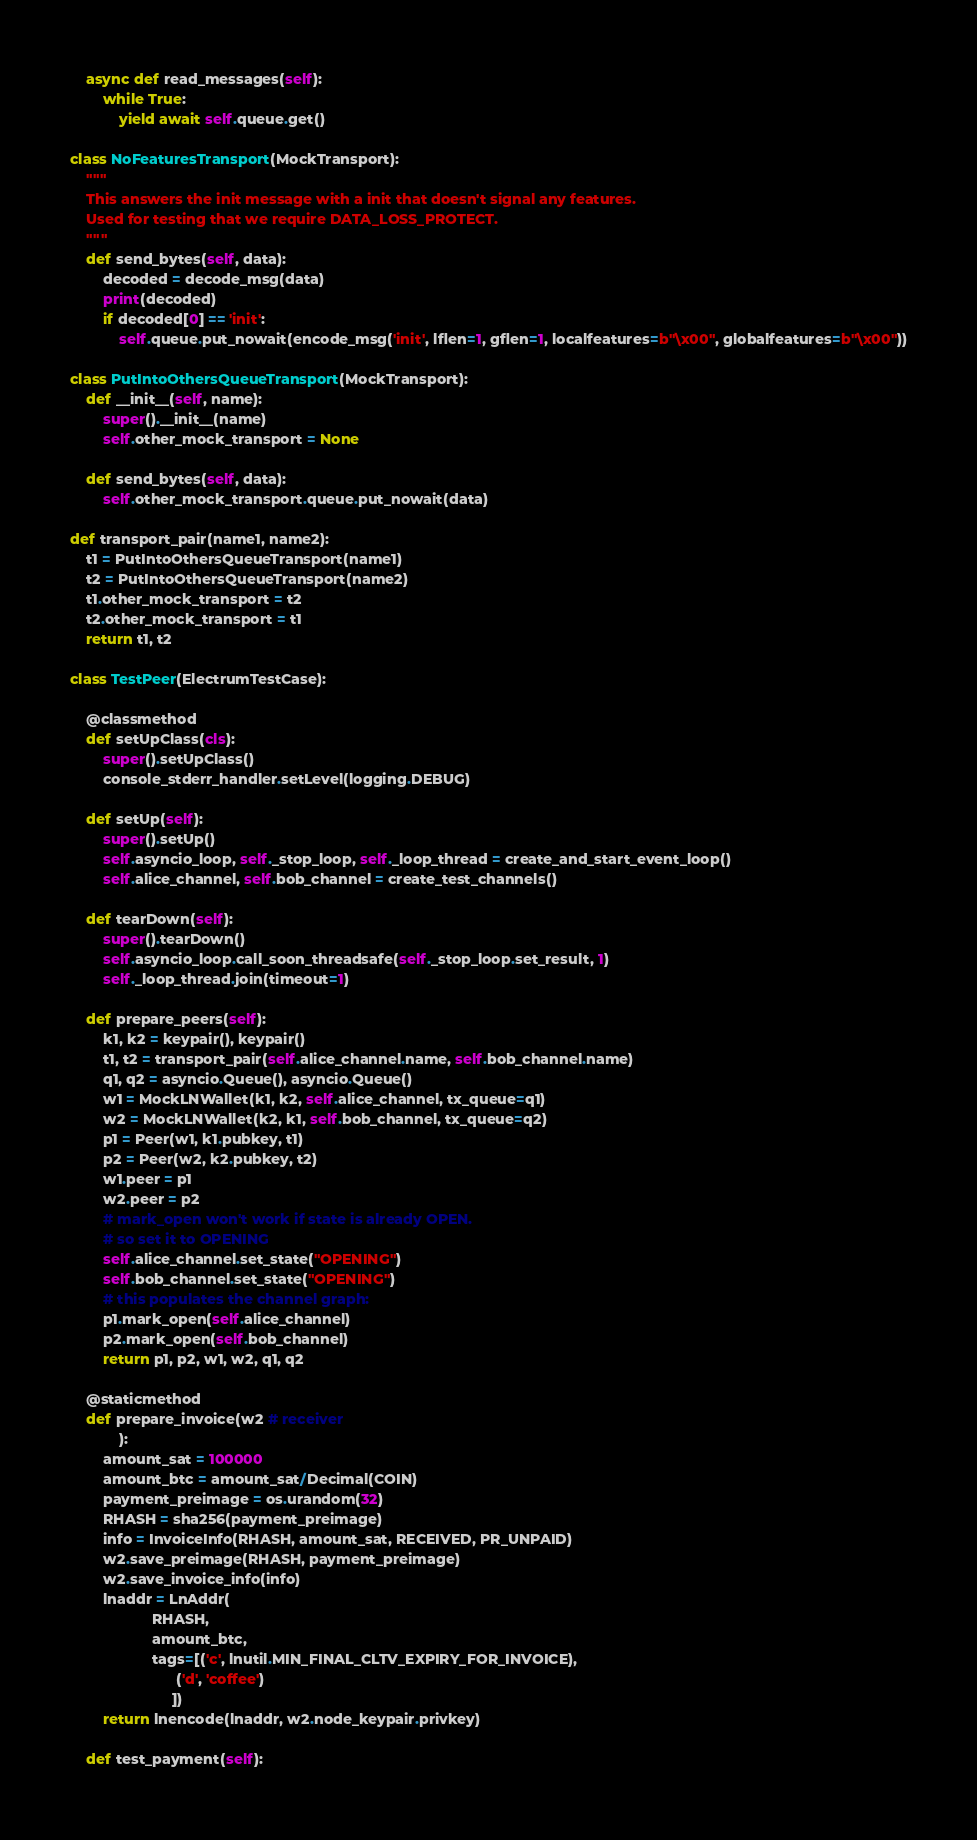Convert code to text. <code><loc_0><loc_0><loc_500><loc_500><_Python_>    async def read_messages(self):
        while True:
            yield await self.queue.get()

class NoFeaturesTransport(MockTransport):
    """
    This answers the init message with a init that doesn't signal any features.
    Used for testing that we require DATA_LOSS_PROTECT.
    """
    def send_bytes(self, data):
        decoded = decode_msg(data)
        print(decoded)
        if decoded[0] == 'init':
            self.queue.put_nowait(encode_msg('init', lflen=1, gflen=1, localfeatures=b"\x00", globalfeatures=b"\x00"))

class PutIntoOthersQueueTransport(MockTransport):
    def __init__(self, name):
        super().__init__(name)
        self.other_mock_transport = None

    def send_bytes(self, data):
        self.other_mock_transport.queue.put_nowait(data)

def transport_pair(name1, name2):
    t1 = PutIntoOthersQueueTransport(name1)
    t2 = PutIntoOthersQueueTransport(name2)
    t1.other_mock_transport = t2
    t2.other_mock_transport = t1
    return t1, t2

class TestPeer(ElectrumTestCase):

    @classmethod
    def setUpClass(cls):
        super().setUpClass()
        console_stderr_handler.setLevel(logging.DEBUG)

    def setUp(self):
        super().setUp()
        self.asyncio_loop, self._stop_loop, self._loop_thread = create_and_start_event_loop()
        self.alice_channel, self.bob_channel = create_test_channels()

    def tearDown(self):
        super().tearDown()
        self.asyncio_loop.call_soon_threadsafe(self._stop_loop.set_result, 1)
        self._loop_thread.join(timeout=1)

    def prepare_peers(self):
        k1, k2 = keypair(), keypair()
        t1, t2 = transport_pair(self.alice_channel.name, self.bob_channel.name)
        q1, q2 = asyncio.Queue(), asyncio.Queue()
        w1 = MockLNWallet(k1, k2, self.alice_channel, tx_queue=q1)
        w2 = MockLNWallet(k2, k1, self.bob_channel, tx_queue=q2)
        p1 = Peer(w1, k1.pubkey, t1)
        p2 = Peer(w2, k2.pubkey, t2)
        w1.peer = p1
        w2.peer = p2
        # mark_open won't work if state is already OPEN.
        # so set it to OPENING
        self.alice_channel.set_state("OPENING")
        self.bob_channel.set_state("OPENING")
        # this populates the channel graph:
        p1.mark_open(self.alice_channel)
        p2.mark_open(self.bob_channel)
        return p1, p2, w1, w2, q1, q2

    @staticmethod
    def prepare_invoice(w2 # receiver
            ):
        amount_sat = 100000
        amount_btc = amount_sat/Decimal(COIN)
        payment_preimage = os.urandom(32)
        RHASH = sha256(payment_preimage)
        info = InvoiceInfo(RHASH, amount_sat, RECEIVED, PR_UNPAID)
        w2.save_preimage(RHASH, payment_preimage)
        w2.save_invoice_info(info)
        lnaddr = LnAddr(
                    RHASH,
                    amount_btc,
                    tags=[('c', lnutil.MIN_FINAL_CLTV_EXPIRY_FOR_INVOICE),
                          ('d', 'coffee')
                         ])
        return lnencode(lnaddr, w2.node_keypair.privkey)

    def test_payment(self):</code> 